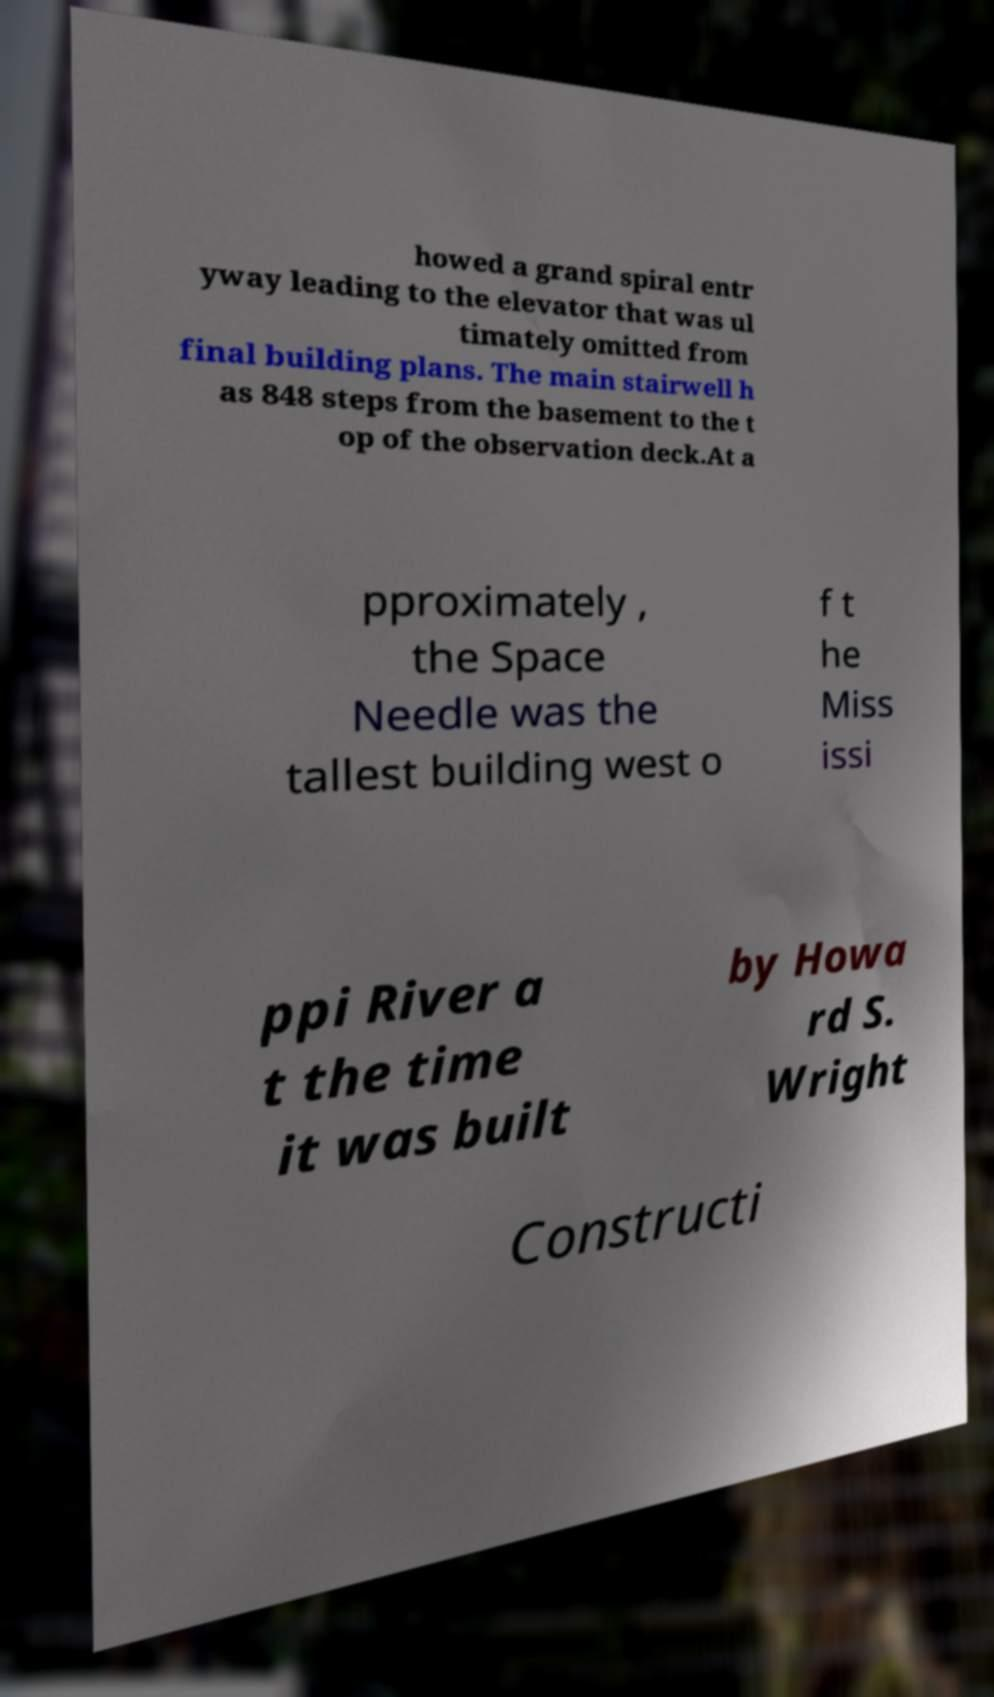Please identify and transcribe the text found in this image. howed a grand spiral entr yway leading to the elevator that was ul timately omitted from final building plans. The main stairwell h as 848 steps from the basement to the t op of the observation deck.At a pproximately , the Space Needle was the tallest building west o f t he Miss issi ppi River a t the time it was built by Howa rd S. Wright Constructi 